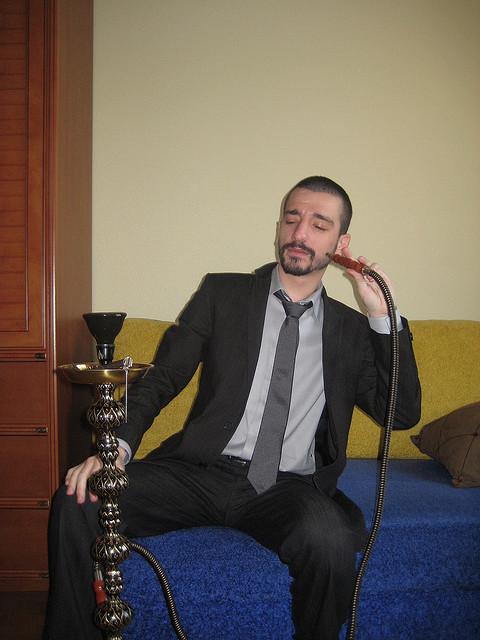What is this man doing?
Short answer required. Smoking. What type of haircut does the man have?
Answer briefly. Buzz. What is the man sitting on?
Write a very short answer. Couch. 